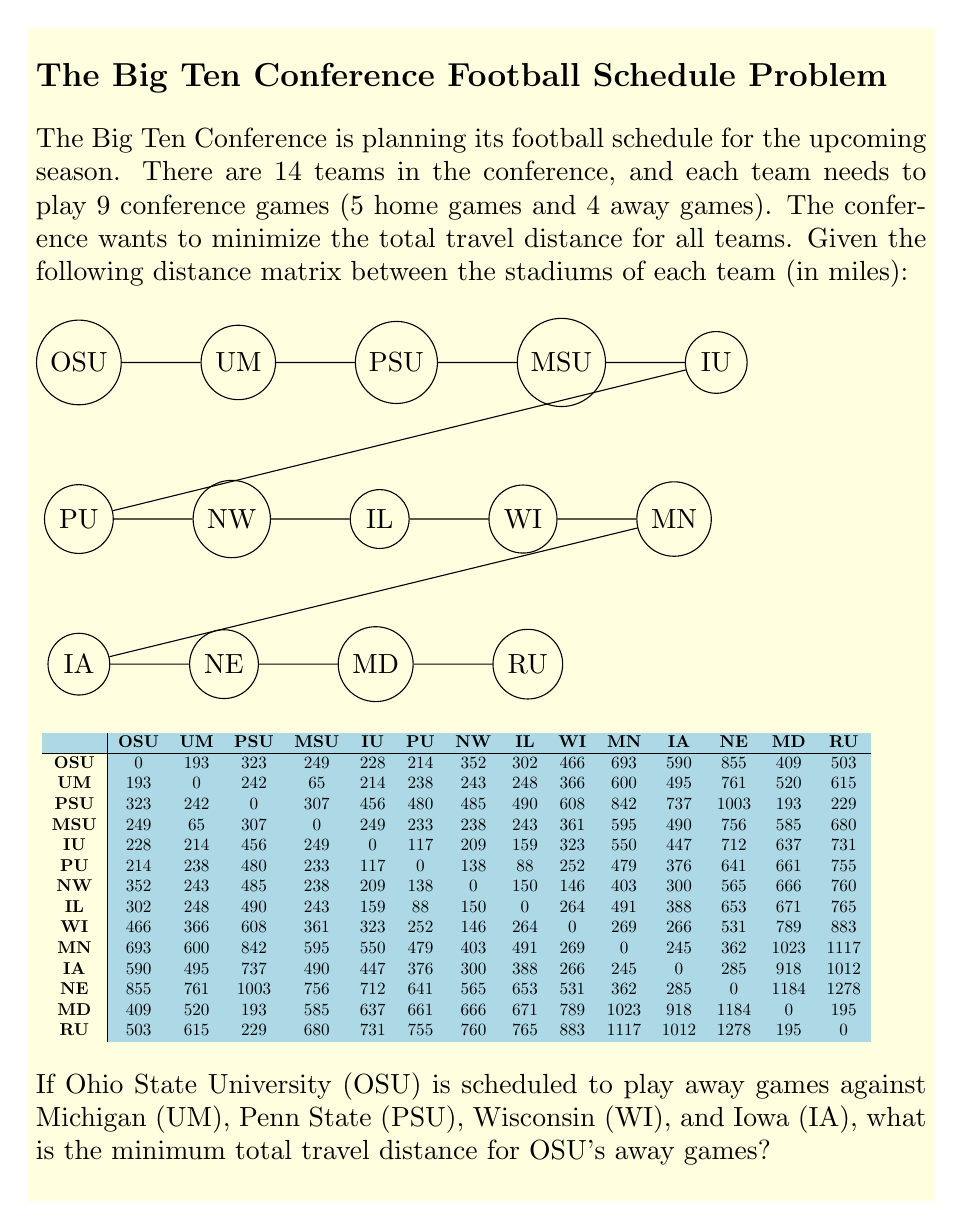Can you answer this question? To solve this problem, we need to follow these steps:

1. Identify the relevant distances from the distance matrix:
   - OSU to UM: 193 miles
   - OSU to PSU: 323 miles
   - OSU to WI: 466 miles
   - OSU to IA: 590 miles

2. Calculate the total travel distance:
   $$\text{Total Distance} = 193 + 323 + 466 + 590 = 1572 \text{ miles}$$

3. Note that this is already the minimum total travel distance for OSU's away games because:
   a) The question specifies these exact four away games.
   b) Each game requires a round trip, so the order of games doesn't affect the total distance.
   c) We assume that OSU returns to Columbus after each away game.

4. If we wanted to optimize the order of games to minimize consecutive travel (although it doesn't change the total distance), we could arrange them as follows:
   OSU → UM (193 miles) → PSU (242 miles) → WI (608 miles) → IA (266 miles) → OSU (590 miles)

This order minimizes the distance between consecutive games, but the total distance remains the same.
Answer: 1572 miles 